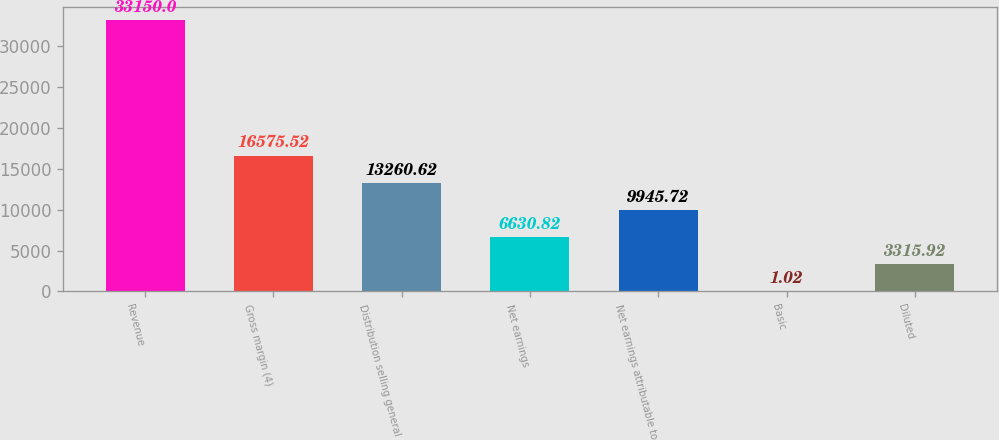Convert chart. <chart><loc_0><loc_0><loc_500><loc_500><bar_chart><fcel>Revenue<fcel>Gross margin (4)<fcel>Distribution selling general<fcel>Net earnings<fcel>Net earnings attributable to<fcel>Basic<fcel>Diluted<nl><fcel>33150<fcel>16575.5<fcel>13260.6<fcel>6630.82<fcel>9945.72<fcel>1.02<fcel>3315.92<nl></chart> 